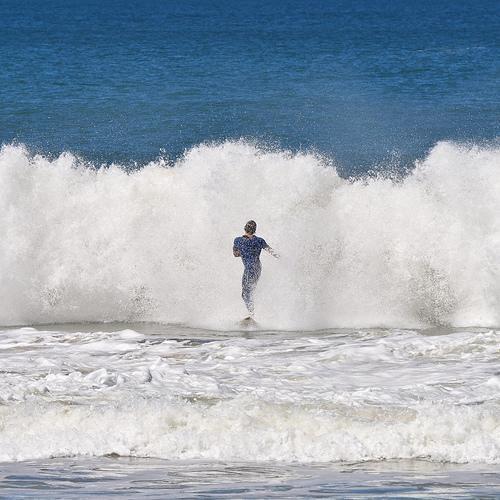How many men are there?
Give a very brief answer. 1. 